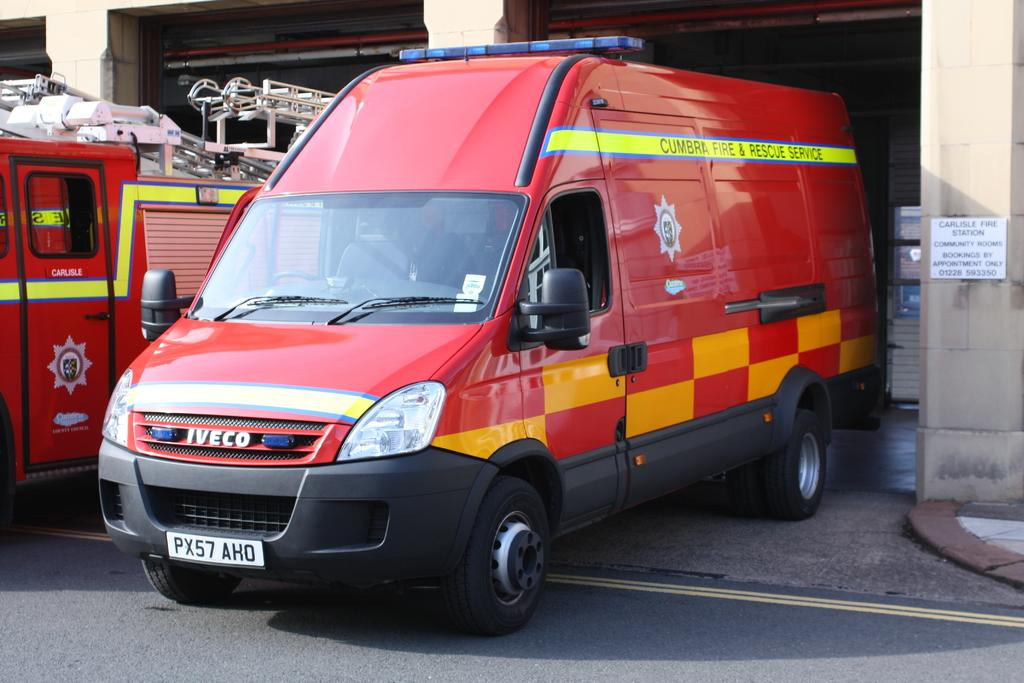Provide a one-sentence caption for the provided image. A Cumbra Fire and Rescue Service vehicle is parked in a garage. 